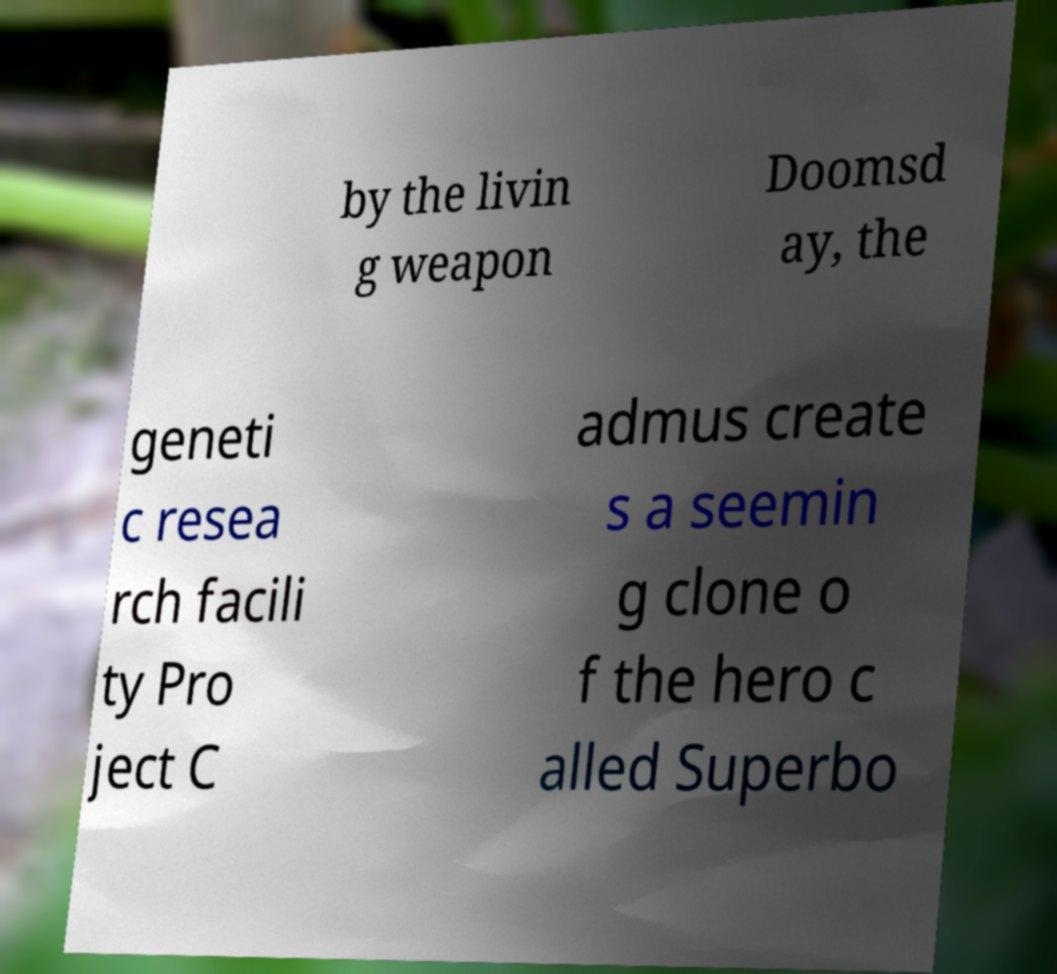Could you assist in decoding the text presented in this image and type it out clearly? by the livin g weapon Doomsd ay, the geneti c resea rch facili ty Pro ject C admus create s a seemin g clone o f the hero c alled Superbo 